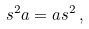Convert formula to latex. <formula><loc_0><loc_0><loc_500><loc_500>s ^ { 2 } a = a s ^ { 2 } \, ,</formula> 